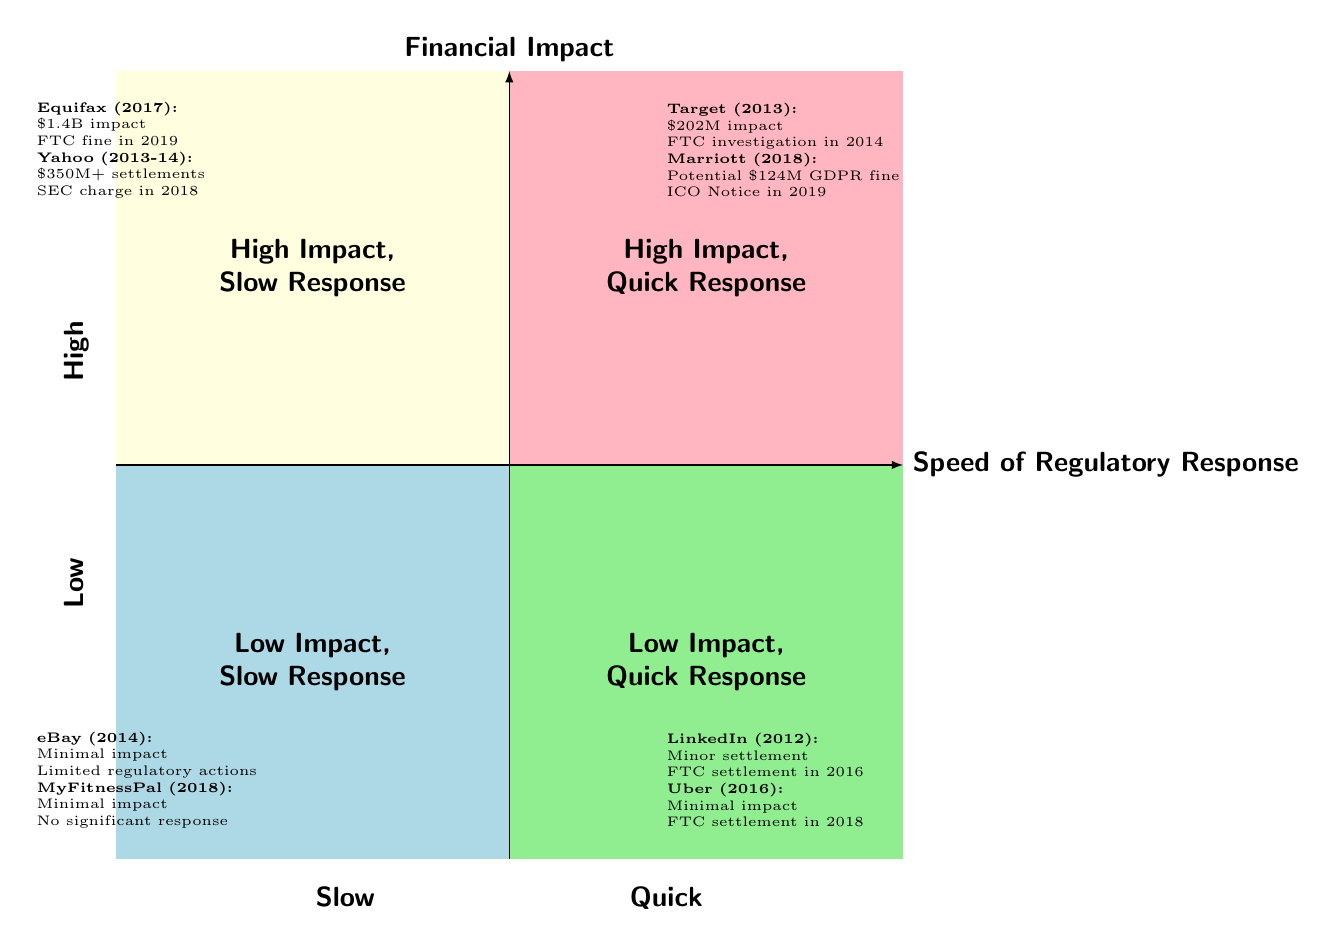What companies are listed in the "High Financial Impact, Slow Regulatory Response" quadrant? The top left quadrant, which represents "High Financial Impact, Slow Regulatory Response," contains Equifax and Yahoo as the examples of companies.
Answer: Equifax, Yahoo What financial impact is associated with the Target data breach incident? To find the financial impact associated with Target's data breach, I refer to the top right quadrant labeled "High Financial Impact, Quick Regulatory Response," which lists it as having a financial impact of $202 million.
Answer: $202 million Which companies experienced "Low Financial Impact, Quick Regulatory Response"? In the bottom right quadrant labeled "Low Financial Impact, Quick Regulatory Response," the companies listed are LinkedIn and Uber.
Answer: LinkedIn, Uber What was the regulatory response for Yahoo regarding their data breach incidents? The information in the top left quadrant provides that Yahoo had a regulatory response in the form of an SEC charge in 2018 following their data breaches in 2013 and 2014.
Answer: SEC charge in 2018 How does the regulatory response speed of eBay compare to that of Marriott? eBay is in the "Low Financial Impact, Slow Regulatory Response" quadrant, with limited regulatory actions mentioned, while Marriott is in the "High Financial Impact, Quick Regulatory Response" quadrant, which indicates a faster response with a Notice of Intent to fine from the ICO.
Answer: Slower for eBay, quicker for Marriott What is the impact of the MyFitnessPal data breach? The bottom left quadrant shows that the MyFitnessPal data breach had a minimal direct financial impact with no significant immediate regulatory response mentioned, indicating a low impact case.
Answer: Minimal direct financial impact How many company incidents are listed in the "High Financial Impact, Quick Regulatory Response" quadrant? In the top right quadrant, there are two companies listed, which are Target and Marriott, indicating two incidents within this category.
Answer: Two What was the potential fine amount associated with Marriott's data breach? In the top right quadrant, it's stated that Marriott faced a potential GDPR fine amounting to $124 million due to their data breach incident in 2018.
Answer: $124 million What characterizes the companies in the bottom left quadrant? The bottom left quadrant is characterized by companies showing "Low Financial Impact, Slow Regulatory Response," specifically highlighting minimal impacts and limited regulatory actions for eBay and MyFitnessPal.
Answer: Low impact, slow response What is the financial impact of the Equifax data breach? The financial impact outlined in the top left quadrant for the Equifax data breach is explicitly mentioned as $1.4 billion.
Answer: $1.4 billion 